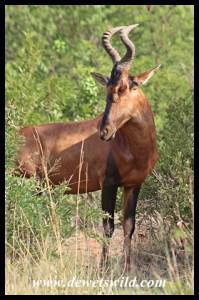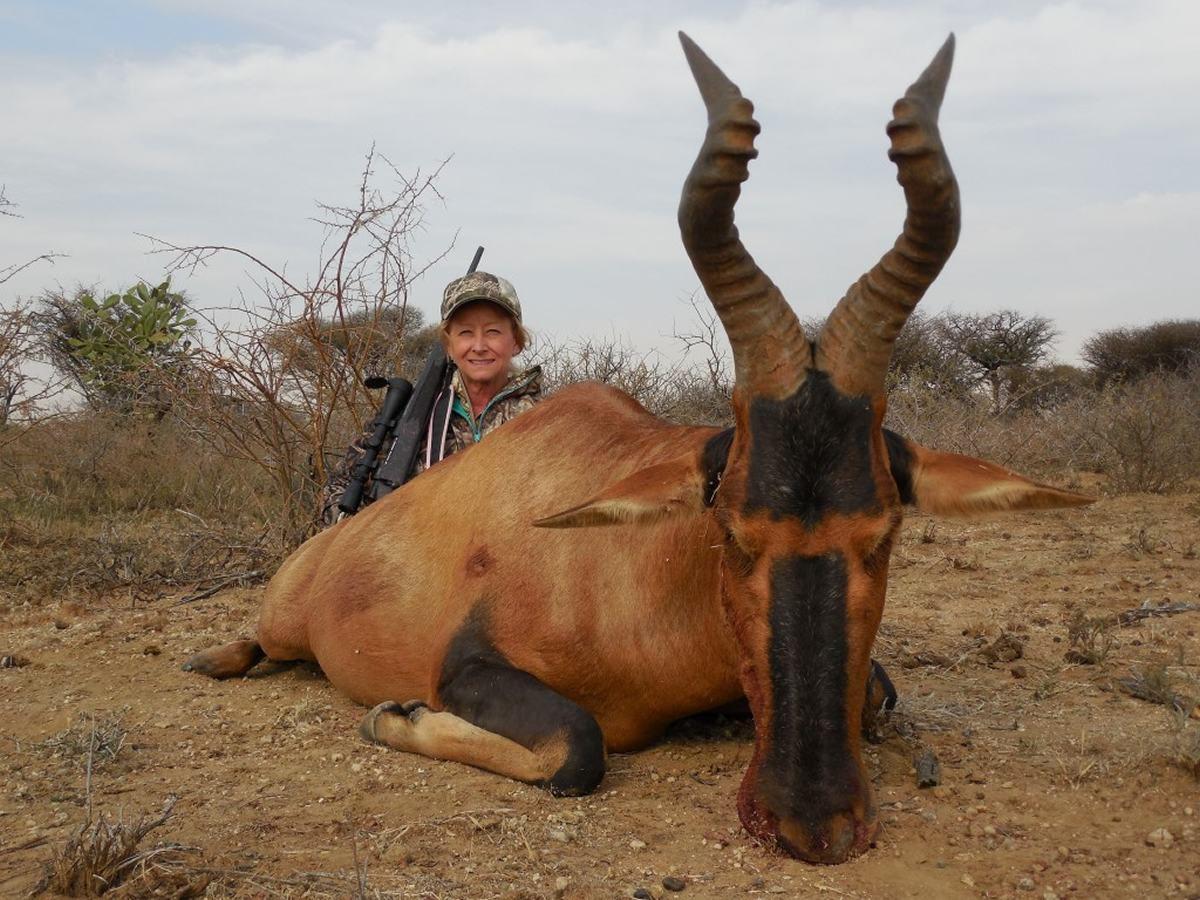The first image is the image on the left, the second image is the image on the right. Assess this claim about the two images: "There are two antelopes in the wild.". Correct or not? Answer yes or no. Yes. The first image is the image on the left, the second image is the image on the right. Assess this claim about the two images: "An image shows one horned animal standing and facing the camera.". Correct or not? Answer yes or no. No. 